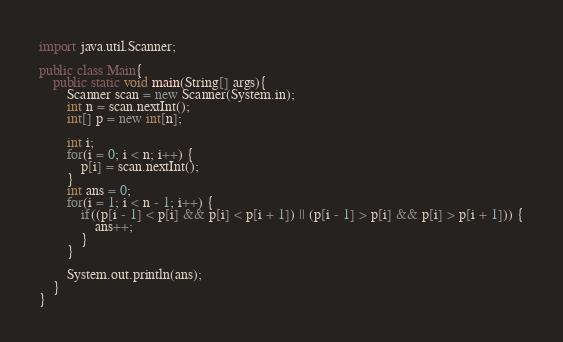Convert code to text. <code><loc_0><loc_0><loc_500><loc_500><_Java_>import java.util.Scanner;

public class Main{
	public static void main(String[] args){
		Scanner scan = new Scanner(System.in);
		int n = scan.nextInt();
		int[] p = new int[n];

		int i;
		for(i = 0; i < n; i++) {
			p[i] = scan.nextInt();
		}
		int ans = 0;
		for(i = 1; i < n - 1; i++) {
			if((p[i - 1] < p[i] && p[i] < p[i + 1]) || (p[i - 1] > p[i] && p[i] > p[i + 1])) {
				ans++;
			}
		}

		System.out.println(ans);
	}
}</code> 